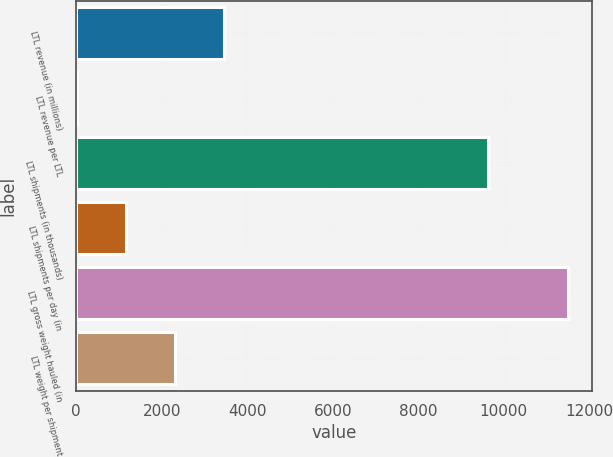Convert chart. <chart><loc_0><loc_0><loc_500><loc_500><bar_chart><fcel>LTL revenue (in millions)<fcel>LTL revenue per LTL<fcel>LTL shipments (in thousands)<fcel>LTL shipments per day (in<fcel>LTL gross weight hauled (in<fcel>LTL weight per shipment<nl><fcel>3460.56<fcel>15.93<fcel>9638<fcel>1164.14<fcel>11498<fcel>2312.35<nl></chart> 